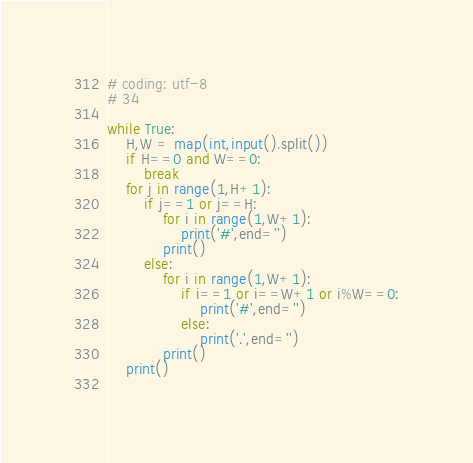Convert code to text. <code><loc_0><loc_0><loc_500><loc_500><_Python_># coding: utf-8
# 34

while True:
    H,W = map(int,input().split())
    if H==0 and W==0:
        break
    for j in range(1,H+1):
        if j==1 or j==H:
            for i in range(1,W+1):
                print('#',end='')
            print()
        else:
            for i in range(1,W+1):
                if i==1 or i==W+1 or i%W==0:
                    print('#',end='')
                else:
                    print('.',end='')
            print()
    print()
    


</code> 